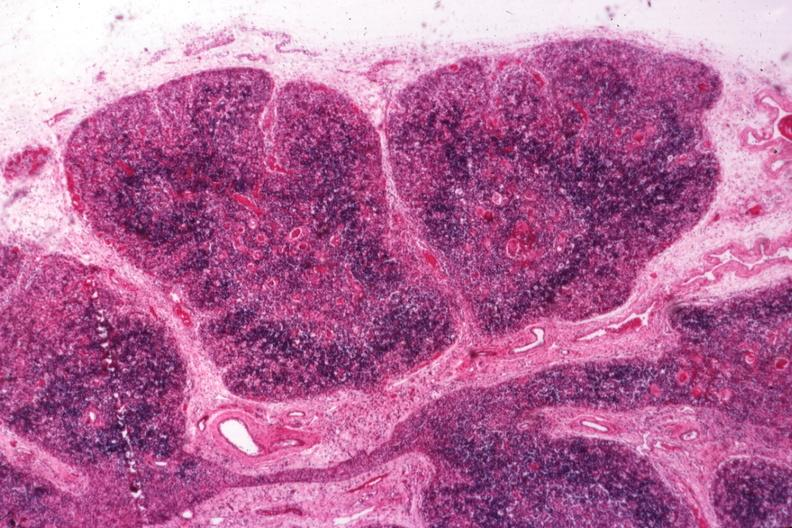what is present?
Answer the question using a single word or phrase. Lymphoid atrophy in newborn 